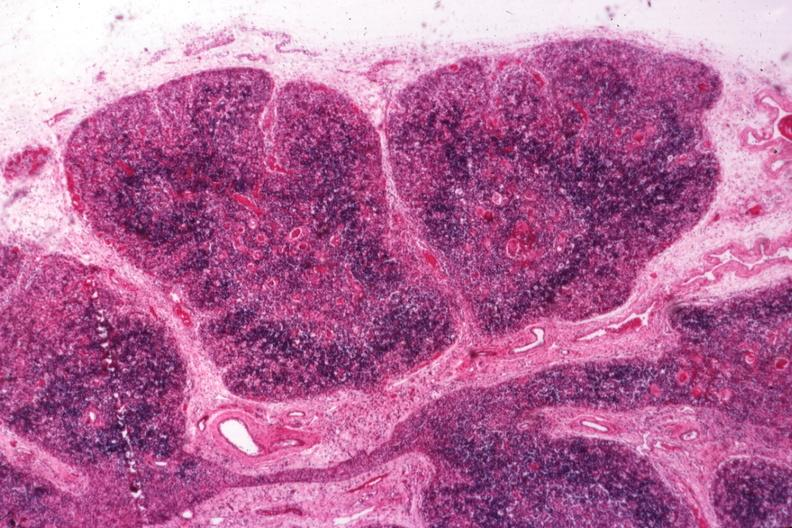what is present?
Answer the question using a single word or phrase. Lymphoid atrophy in newborn 